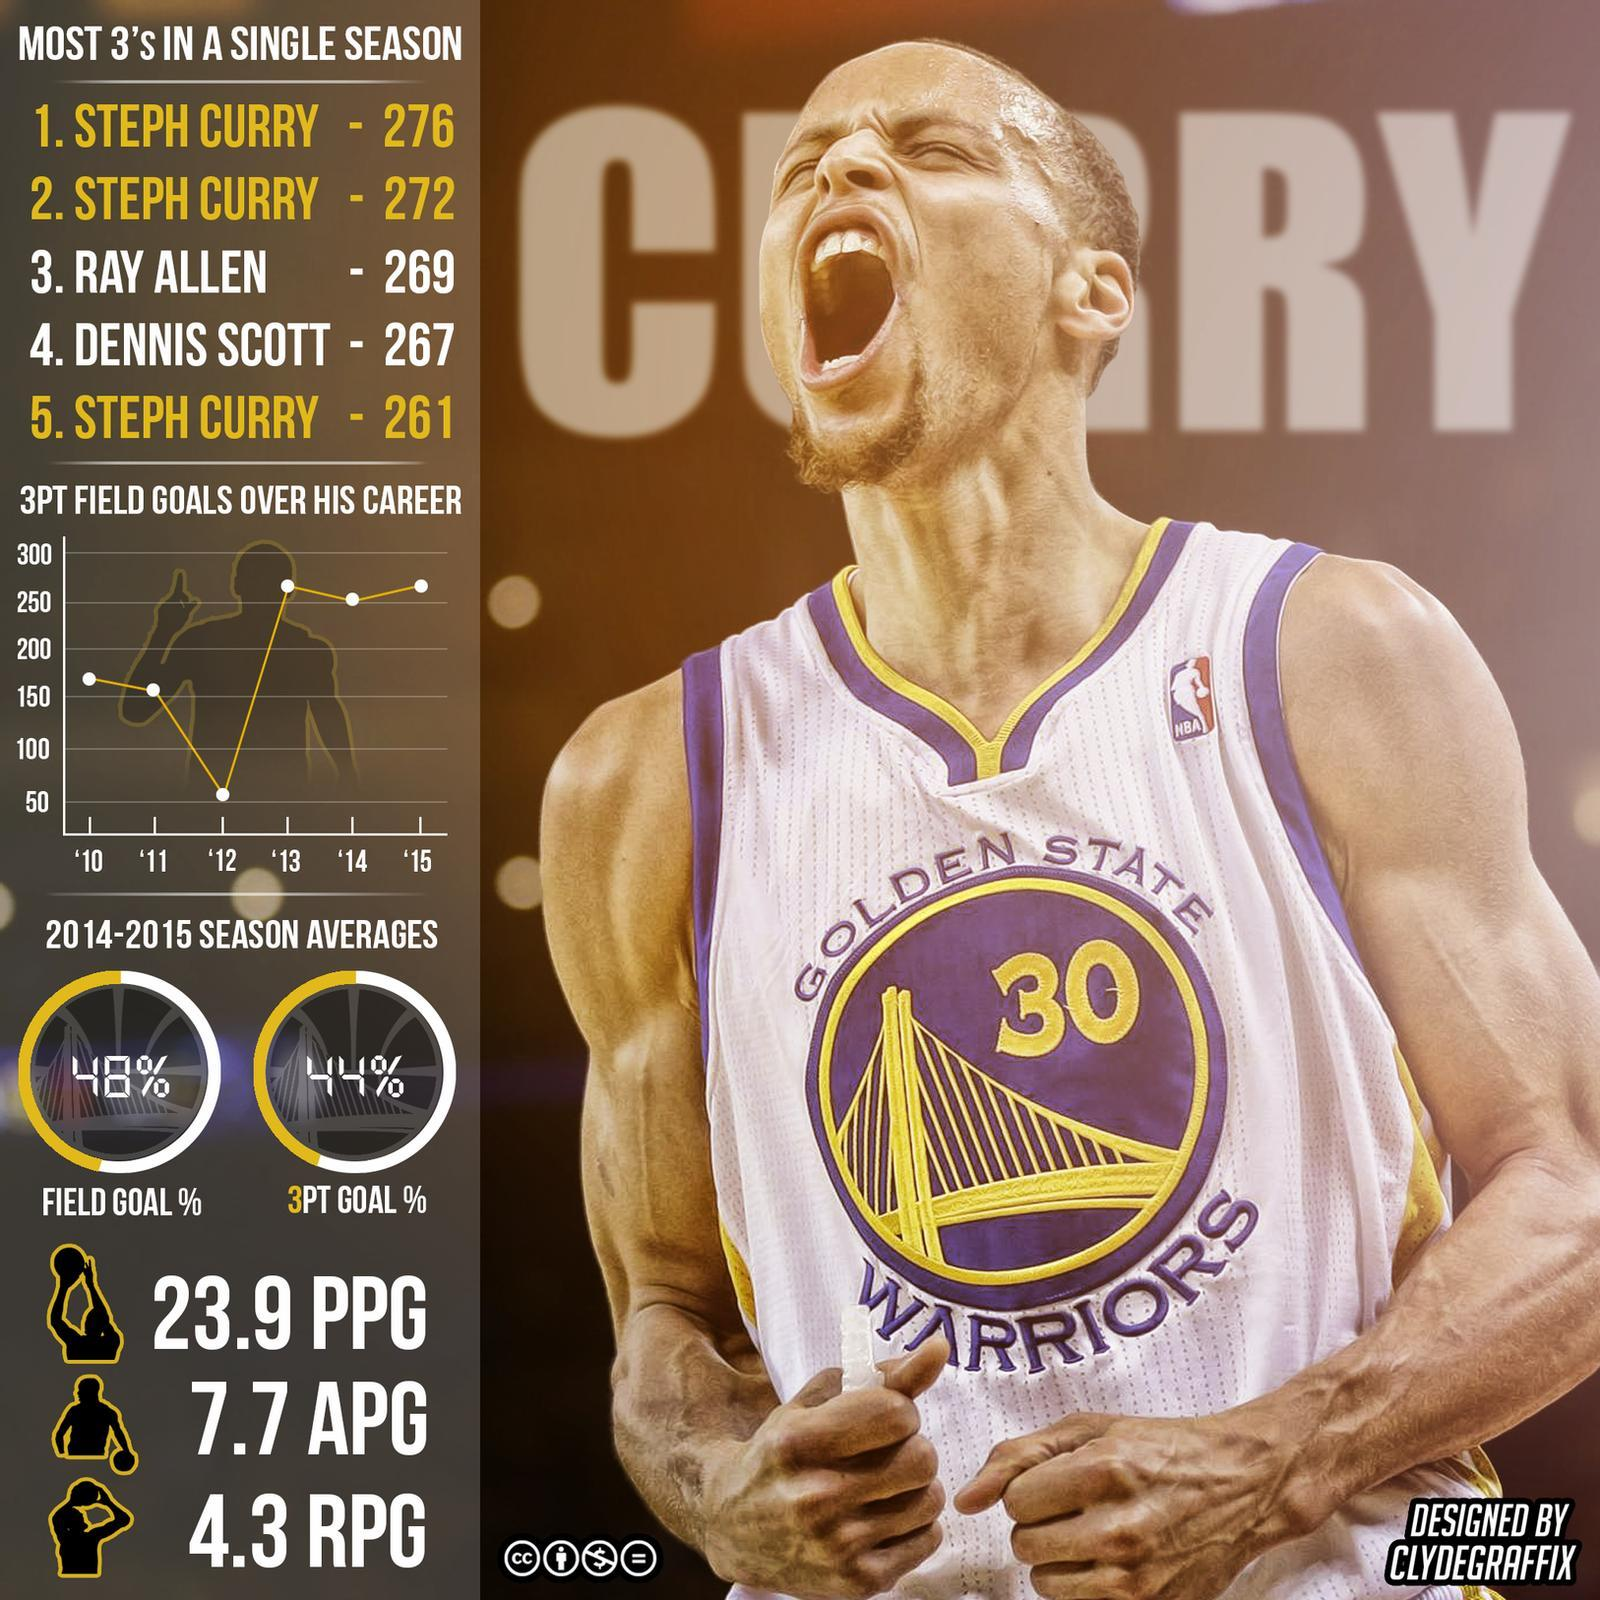What is the assists given by Steph Curry  per game ?
Answer the question with a short phrase. 7.7 What are the rebounds per game given by Steph Curry? 4.3 When did Steph Curry score his least 3 point field goals,  2010, 2011, 2012, 2014, or 2015? 2012 What is the points per game scored by Steph Curry? 23.9 Who scored the most 3 points in a three seasons? Steph Curry 